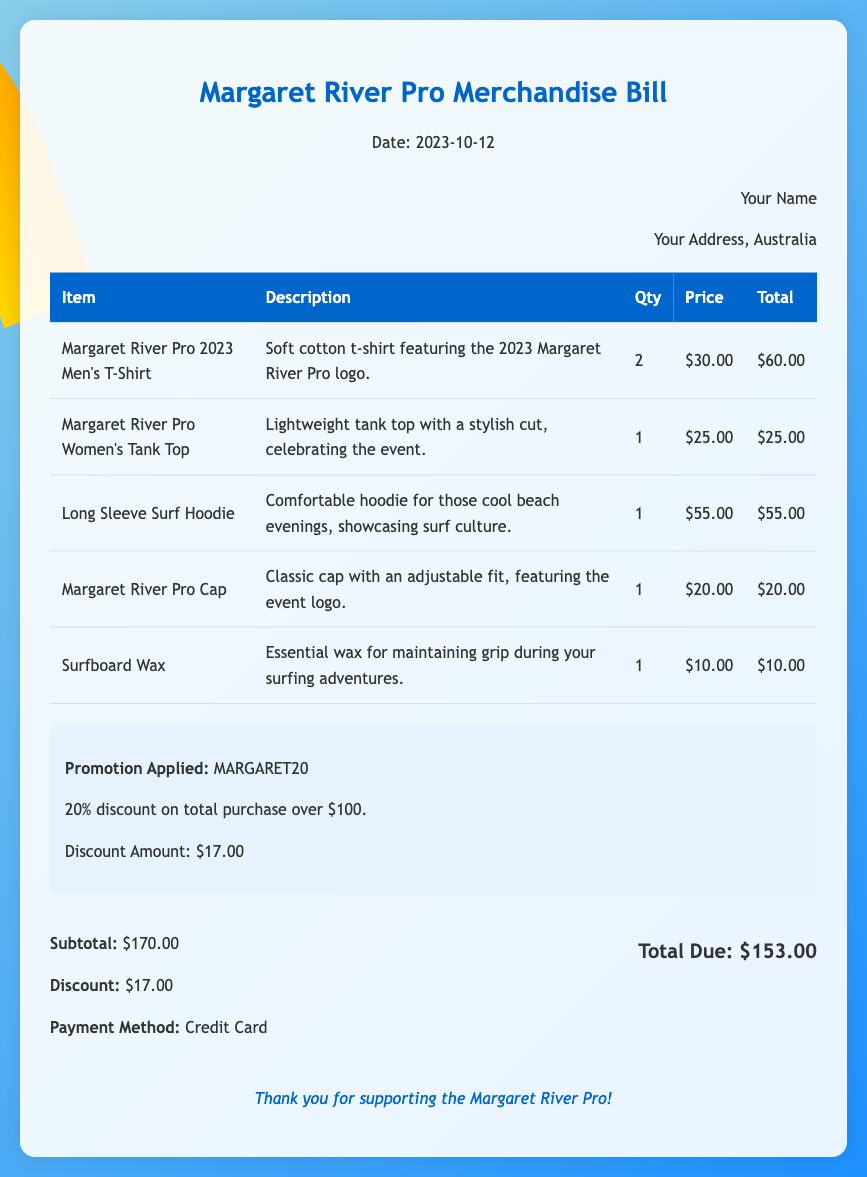What is the date of the bill? The date of the bill is specified in the document header.
Answer: 2023-10-12 How many Men's T-Shirts were purchased? The quantity of Men's T-Shirts is listed in the item row of the table.
Answer: 2 What was the discount code applied? The promotion section details the discount code used on the purchase.
Answer: MARGARET20 What is the total due amount after the discount? The total due is calculated by subtracting the discount amount from the subtotal.
Answer: $153.00 How much was the discount amount? The discount amount is specified in the promotion section of the document.
Answer: $17.00 What is the price of the Long Sleeve Surf Hoodie? The price for the Long Sleeve Surf Hoodie is listed in the items table.
Answer: $55.00 What payment method was used? The payment method is mentioned in the summary section of the document.
Answer: Credit Card What item features the event logo? This item is mentioned in the description of the cap.
Answer: Margaret River Pro Cap How many total items were purchased? The total number of items is the sum of quantities in the items table.
Answer: 5 